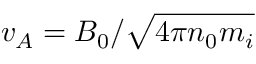Convert formula to latex. <formula><loc_0><loc_0><loc_500><loc_500>v _ { A } = B _ { 0 } / \sqrt { 4 \pi n _ { 0 } m _ { i } }</formula> 